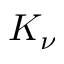<formula> <loc_0><loc_0><loc_500><loc_500>K _ { \nu }</formula> 